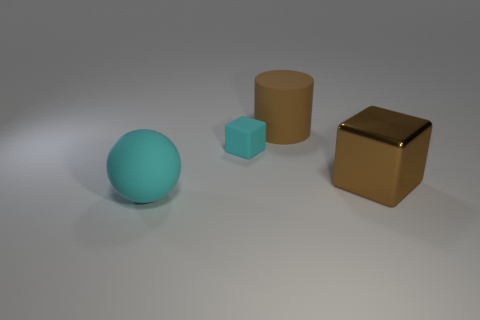Add 1 big cubes. How many objects exist? 5 Subtract all cyan blocks. How many blocks are left? 1 Subtract 0 blue cylinders. How many objects are left? 4 Subtract all cylinders. How many objects are left? 3 Subtract 1 cylinders. How many cylinders are left? 0 Subtract all gray cubes. Subtract all yellow cylinders. How many cubes are left? 2 Subtract all cyan cylinders. How many gray balls are left? 0 Subtract all big brown rubber cylinders. Subtract all tiny things. How many objects are left? 2 Add 4 big rubber things. How many big rubber things are left? 6 Add 2 big brown cubes. How many big brown cubes exist? 3 